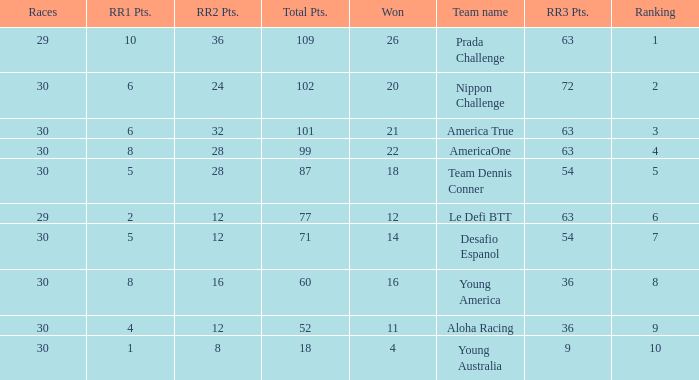Which 7 rankings have the most rr1 points? 5.0. Could you parse the entire table? {'header': ['Races', 'RR1 Pts.', 'RR2 Pts.', 'Total Pts.', 'Won', 'Team name', 'RR3 Pts.', 'Ranking'], 'rows': [['29', '10', '36', '109', '26', 'Prada Challenge', '63', '1'], ['30', '6', '24', '102', '20', 'Nippon Challenge', '72', '2'], ['30', '6', '32', '101', '21', 'America True', '63', '3'], ['30', '8', '28', '99', '22', 'AmericaOne', '63', '4'], ['30', '5', '28', '87', '18', 'Team Dennis Conner', '54', '5'], ['29', '2', '12', '77', '12', 'Le Defi BTT', '63', '6'], ['30', '5', '12', '71', '14', 'Desafio Espanol', '54', '7'], ['30', '8', '16', '60', '16', 'Young America', '36', '8'], ['30', '4', '12', '52', '11', 'Aloha Racing', '36', '9'], ['30', '1', '8', '18', '4', 'Young Australia', '9', '10']]} 